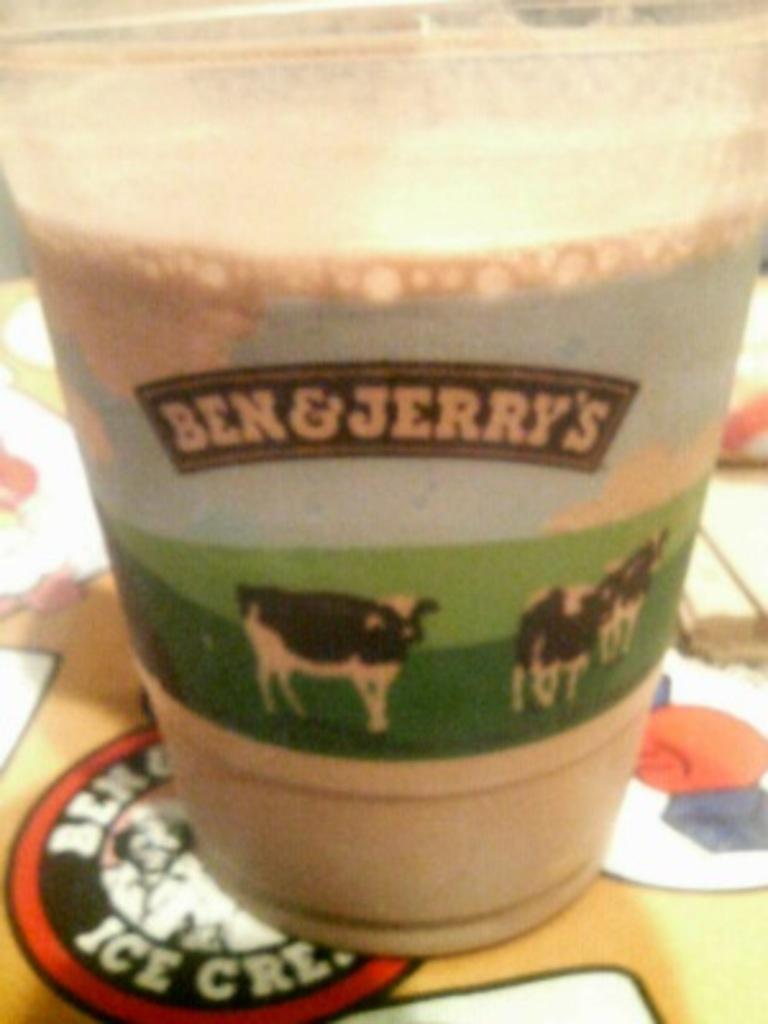Can you describe this image briefly? In this picture there is a glass placed on the table. The glass is filled with the liquid. On the glass there are pictures of cows and some text. 